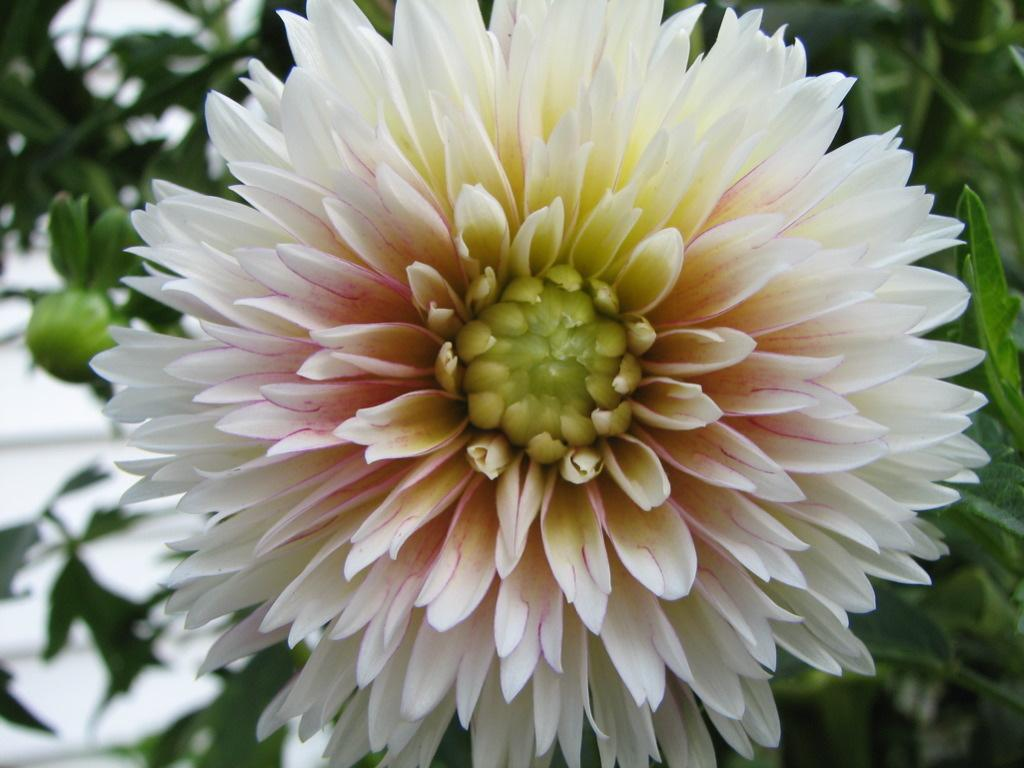What is the main subject of the image? There is a flower in the image. Can you describe the colors of the flower? The flower has white and pink colors. What can be seen in the background of the image? There is a plant or tree in the background of the image. How is the background of the image depicted? The background is blurred. How many books are stacked next to the flower in the image? There are no books present in the image; it only features a flower and a blurred background. 